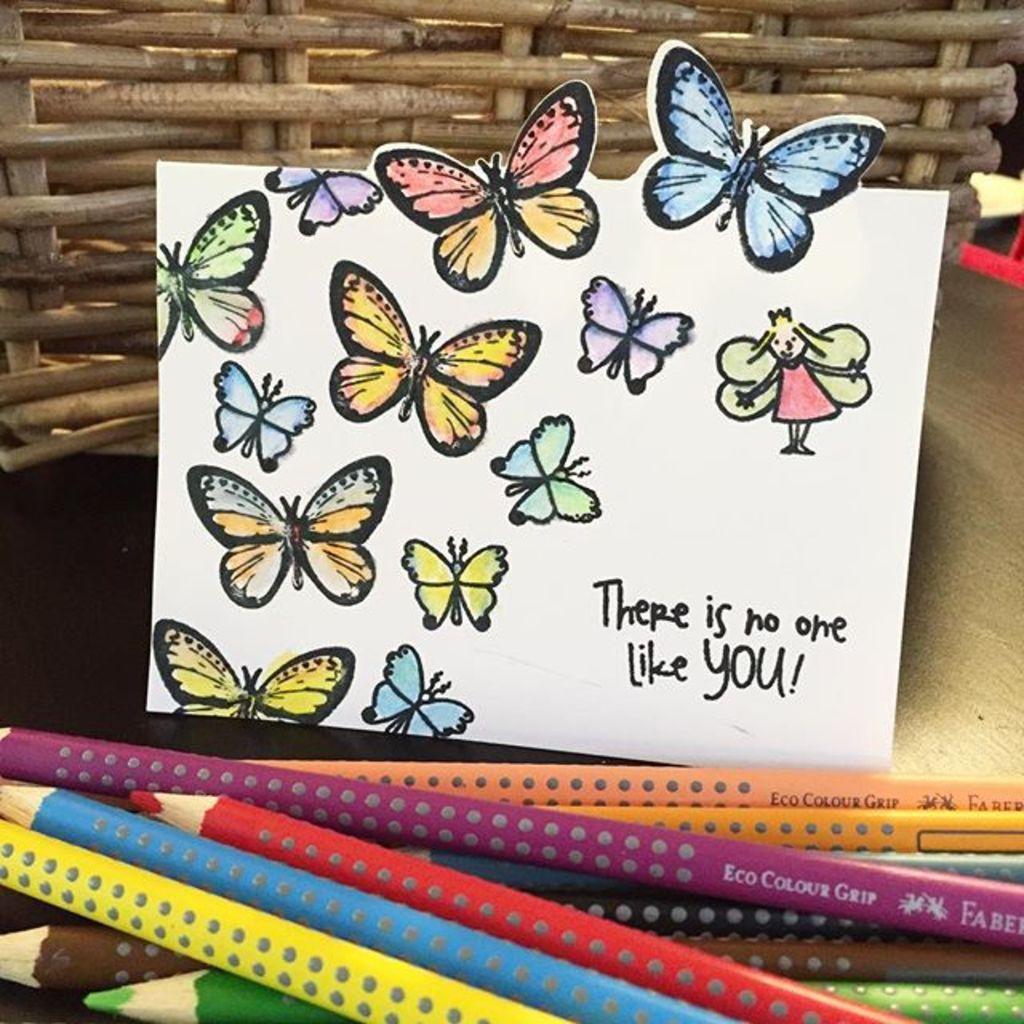Could you give a brief overview of what you see in this image? In this picture we can see a basket,poster and color pencils. 